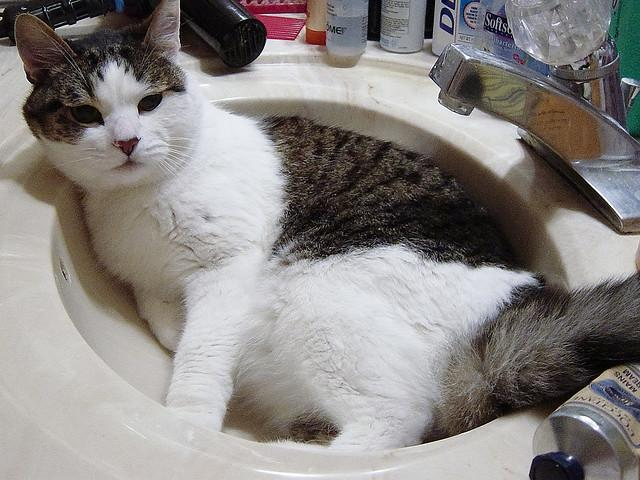Why is the cat in the sink? Please explain your reasoning. to sleep. Cats love to sleep and rest in sinks. 